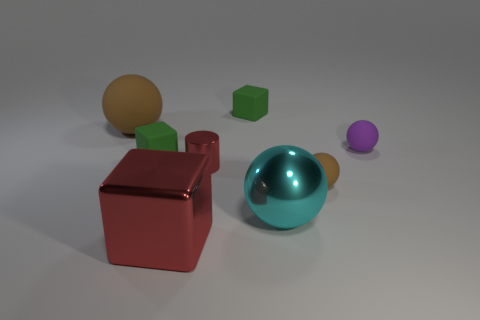Add 1 tiny purple objects. How many objects exist? 9 Subtract all cylinders. How many objects are left? 7 Subtract 1 purple balls. How many objects are left? 7 Subtract all yellow metallic cylinders. Subtract all tiny balls. How many objects are left? 6 Add 1 small green matte blocks. How many small green matte blocks are left? 3 Add 2 large red metal things. How many large red metal things exist? 3 